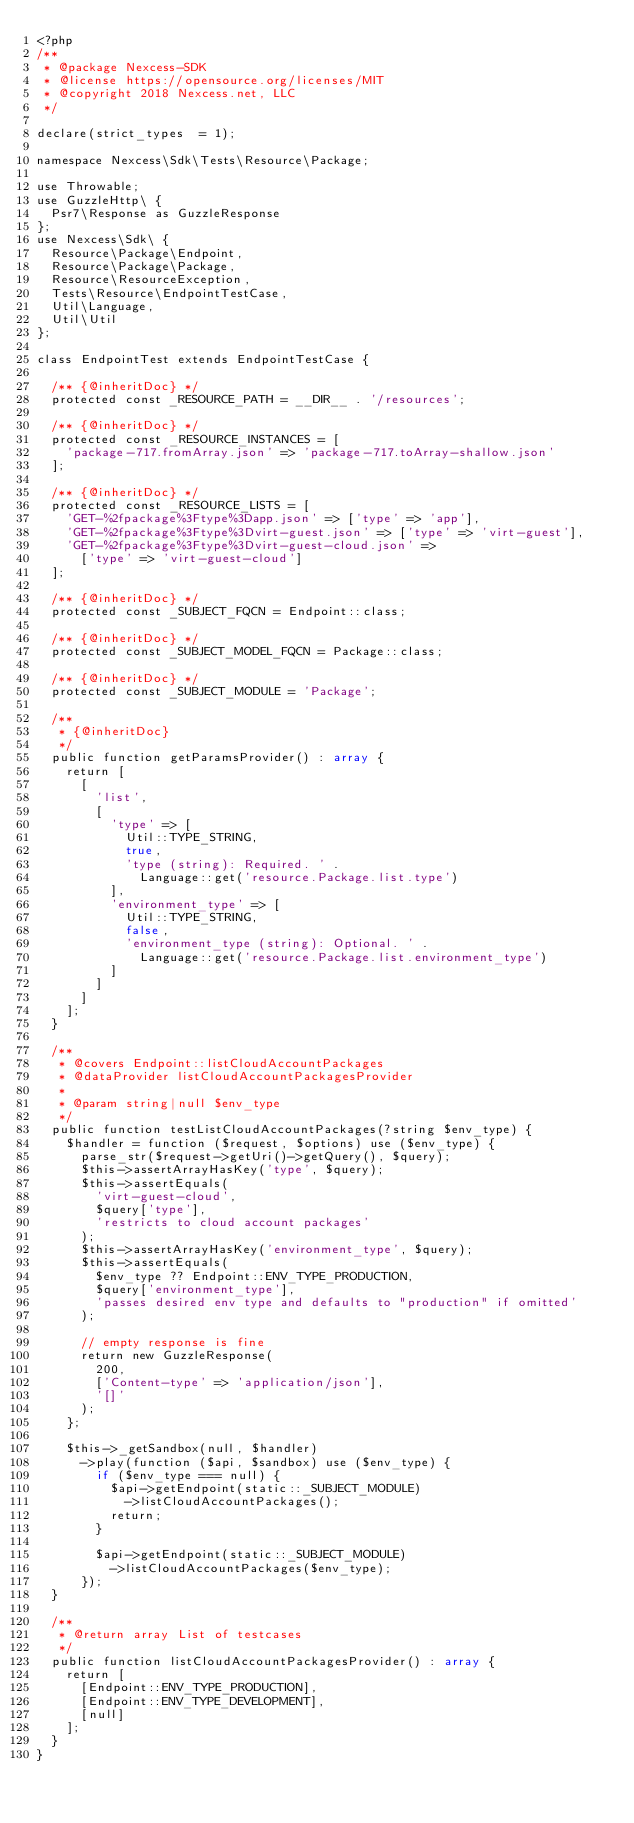Convert code to text. <code><loc_0><loc_0><loc_500><loc_500><_PHP_><?php
/**
 * @package Nexcess-SDK
 * @license https://opensource.org/licenses/MIT
 * @copyright 2018 Nexcess.net, LLC
 */

declare(strict_types  = 1);

namespace Nexcess\Sdk\Tests\Resource\Package;

use Throwable;
use GuzzleHttp\ {
  Psr7\Response as GuzzleResponse
};
use Nexcess\Sdk\ {
  Resource\Package\Endpoint,
  Resource\Package\Package,
  Resource\ResourceException,
  Tests\Resource\EndpointTestCase,
  Util\Language,
  Util\Util
};

class EndpointTest extends EndpointTestCase {

  /** {@inheritDoc} */
  protected const _RESOURCE_PATH = __DIR__ . '/resources';

  /** {@inheritDoc} */
  protected const _RESOURCE_INSTANCES = [
    'package-717.fromArray.json' => 'package-717.toArray-shallow.json'
  ];

  /** {@inheritDoc} */
  protected const _RESOURCE_LISTS = [
    'GET-%2fpackage%3Ftype%3Dapp.json' => ['type' => 'app'],
    'GET-%2fpackage%3Ftype%3Dvirt-guest.json' => ['type' => 'virt-guest'],
    'GET-%2fpackage%3Ftype%3Dvirt-guest-cloud.json' =>
      ['type' => 'virt-guest-cloud']
  ];

  /** {@inheritDoc} */
  protected const _SUBJECT_FQCN = Endpoint::class;

  /** {@inheritDoc} */
  protected const _SUBJECT_MODEL_FQCN = Package::class;

  /** {@inheritDoc} */
  protected const _SUBJECT_MODULE = 'Package';

  /**
   * {@inheritDoc}
   */
  public function getParamsProvider() : array {
    return [
      [
        'list',
        [
          'type' => [
            Util::TYPE_STRING,
            true,
            'type (string): Required. ' .
              Language::get('resource.Package.list.type')
          ],
          'environment_type' => [
            Util::TYPE_STRING,
            false,
            'environment_type (string): Optional. ' .
              Language::get('resource.Package.list.environment_type')
          ]
        ]
      ]
    ];
  }

  /**
   * @covers Endpoint::listCloudAccountPackages
   * @dataProvider listCloudAccountPackagesProvider
   *
   * @param string|null $env_type
   */
  public function testListCloudAccountPackages(?string $env_type) {
    $handler = function ($request, $options) use ($env_type) {
      parse_str($request->getUri()->getQuery(), $query);
      $this->assertArrayHasKey('type', $query);
      $this->assertEquals(
        'virt-guest-cloud',
        $query['type'],
        'restricts to cloud account packages'
      );
      $this->assertArrayHasKey('environment_type', $query);
      $this->assertEquals(
        $env_type ?? Endpoint::ENV_TYPE_PRODUCTION,
        $query['environment_type'],
        'passes desired env type and defaults to "production" if omitted'
      );

      // empty response is fine
      return new GuzzleResponse(
        200,
        ['Content-type' => 'application/json'],
        '[]'
      );
    };

    $this->_getSandbox(null, $handler)
      ->play(function ($api, $sandbox) use ($env_type) {
        if ($env_type === null) {
          $api->getEndpoint(static::_SUBJECT_MODULE)
            ->listCloudAccountPackages();
          return;
        }

        $api->getEndpoint(static::_SUBJECT_MODULE)
          ->listCloudAccountPackages($env_type);
      });
  }

  /**
   * @return array List of testcases
   */
  public function listCloudAccountPackagesProvider() : array {
    return [
      [Endpoint::ENV_TYPE_PRODUCTION],
      [Endpoint::ENV_TYPE_DEVELOPMENT],
      [null]
    ];
  }
}
</code> 